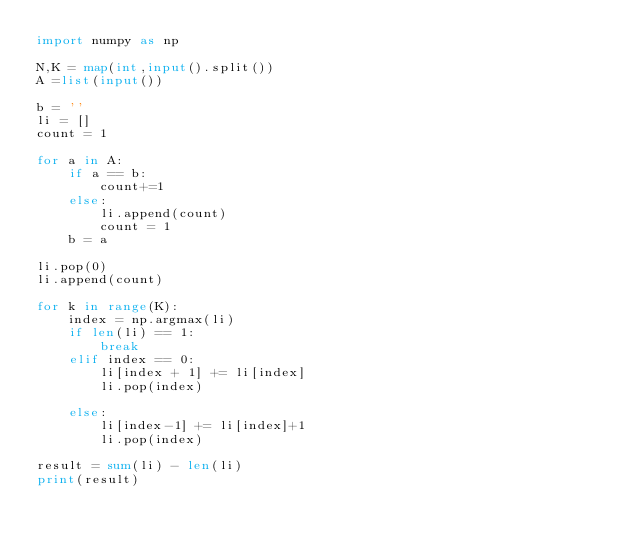<code> <loc_0><loc_0><loc_500><loc_500><_Python_>import numpy as np

N,K = map(int,input().split())
A =list(input())

b = ''
li = []
count = 1

for a in A:
    if a == b:
        count+=1
    else:
        li.append(count)
        count = 1
    b = a

li.pop(0)
li.append(count)

for k in range(K):
    index = np.argmax(li)
    if len(li) == 1:
        break
    elif index == 0:
        li[index + 1] += li[index]
        li.pop(index)

    else:
        li[index-1] += li[index]+1
        li.pop(index)

result = sum(li) - len(li)
print(result)</code> 